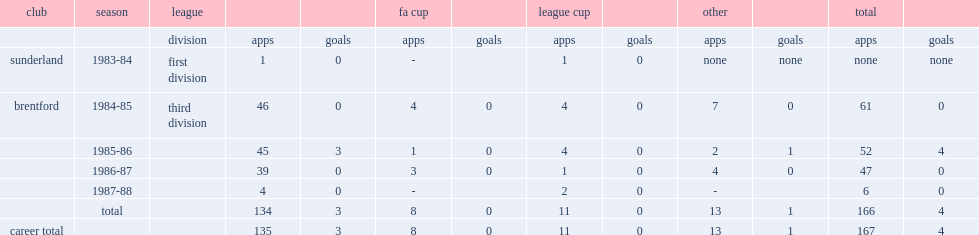Which club did murray play for during the 1984-85 season? Brentford. 